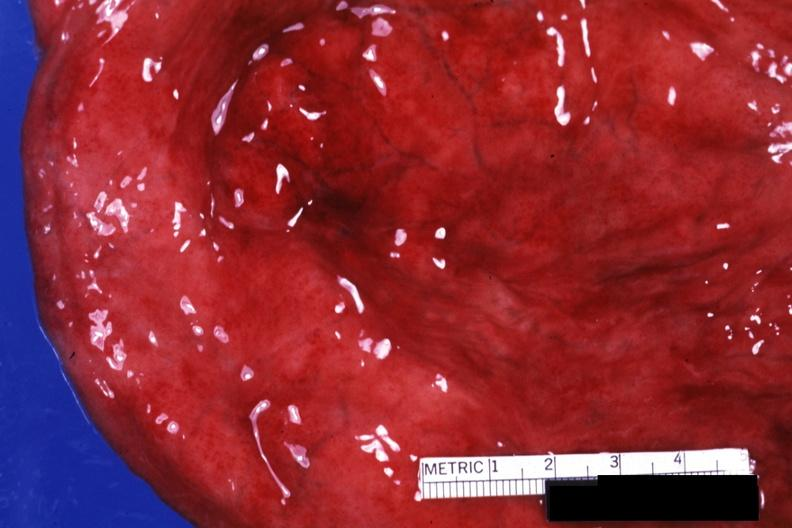s hemorrhagic cystitis present?
Answer the question using a single word or phrase. Yes 